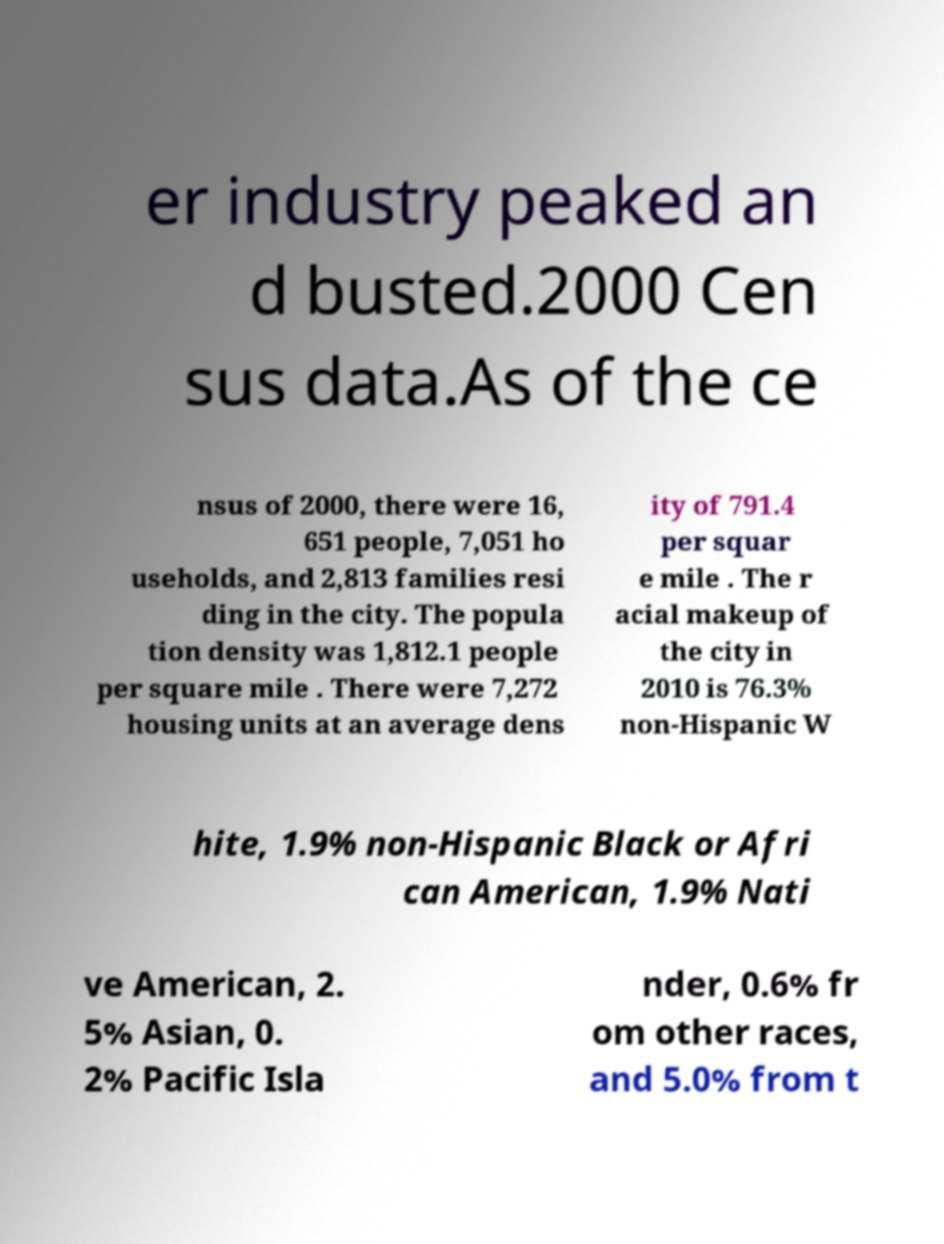Please identify and transcribe the text found in this image. er industry peaked an d busted.2000 Cen sus data.As of the ce nsus of 2000, there were 16, 651 people, 7,051 ho useholds, and 2,813 families resi ding in the city. The popula tion density was 1,812.1 people per square mile . There were 7,272 housing units at an average dens ity of 791.4 per squar e mile . The r acial makeup of the city in 2010 is 76.3% non-Hispanic W hite, 1.9% non-Hispanic Black or Afri can American, 1.9% Nati ve American, 2. 5% Asian, 0. 2% Pacific Isla nder, 0.6% fr om other races, and 5.0% from t 